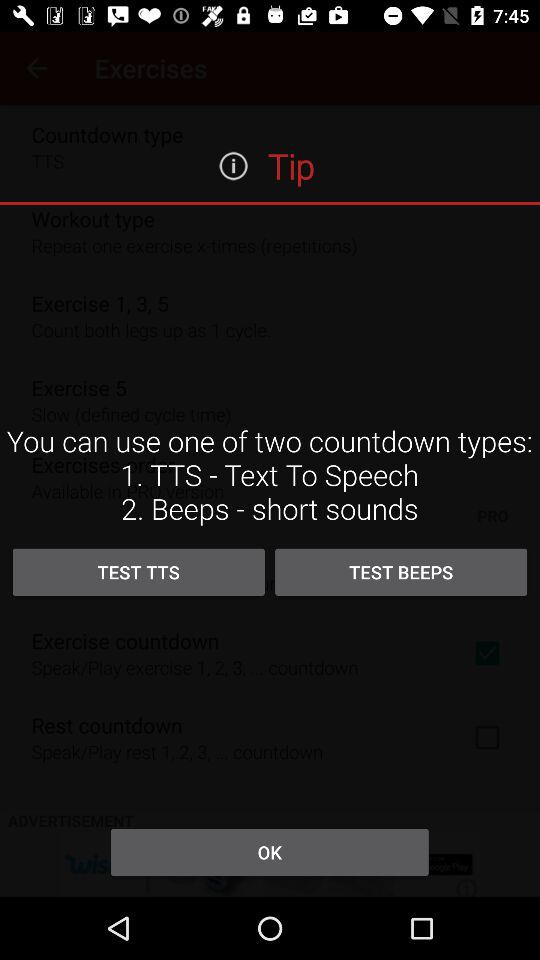What is the full form of TTS? The full form of TTS is "Text To Speech". 